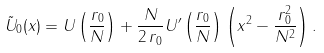<formula> <loc_0><loc_0><loc_500><loc_500>\tilde { U } _ { 0 } ( x ) = U \left ( \frac { r _ { 0 } } { N } \right ) + \frac { N } { 2 \, r _ { 0 } } U ^ { \prime } \left ( \frac { r _ { 0 } } { N } \right ) \left ( x ^ { 2 } - \frac { r _ { 0 } ^ { 2 } } { N ^ { 2 } } \right ) .</formula> 